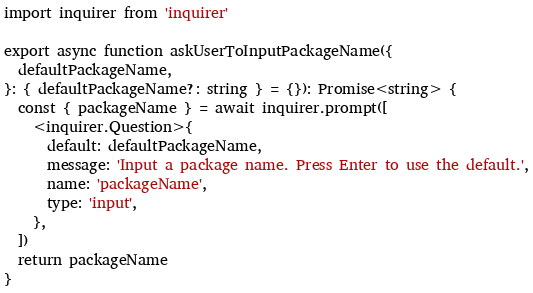Convert code to text. <code><loc_0><loc_0><loc_500><loc_500><_TypeScript_>import inquirer from 'inquirer'

export async function askUserToInputPackageName({
  defaultPackageName,
}: { defaultPackageName?: string } = {}): Promise<string> {
  const { packageName } = await inquirer.prompt([
    <inquirer.Question>{
      default: defaultPackageName,
      message: 'Input a package name. Press Enter to use the default.',
      name: 'packageName',
      type: 'input',
    },
  ])
  return packageName
}
</code> 